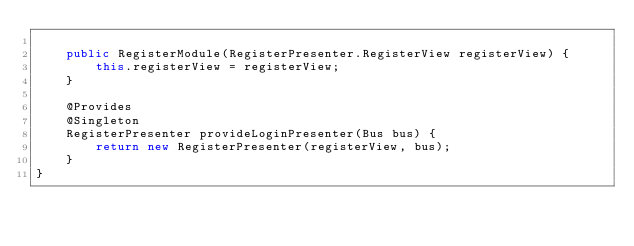Convert code to text. <code><loc_0><loc_0><loc_500><loc_500><_Java_>
    public RegisterModule(RegisterPresenter.RegisterView registerView) {
        this.registerView = registerView;
    }

    @Provides
    @Singleton
    RegisterPresenter provideLoginPresenter(Bus bus) {
        return new RegisterPresenter(registerView, bus);
    }
}
</code> 